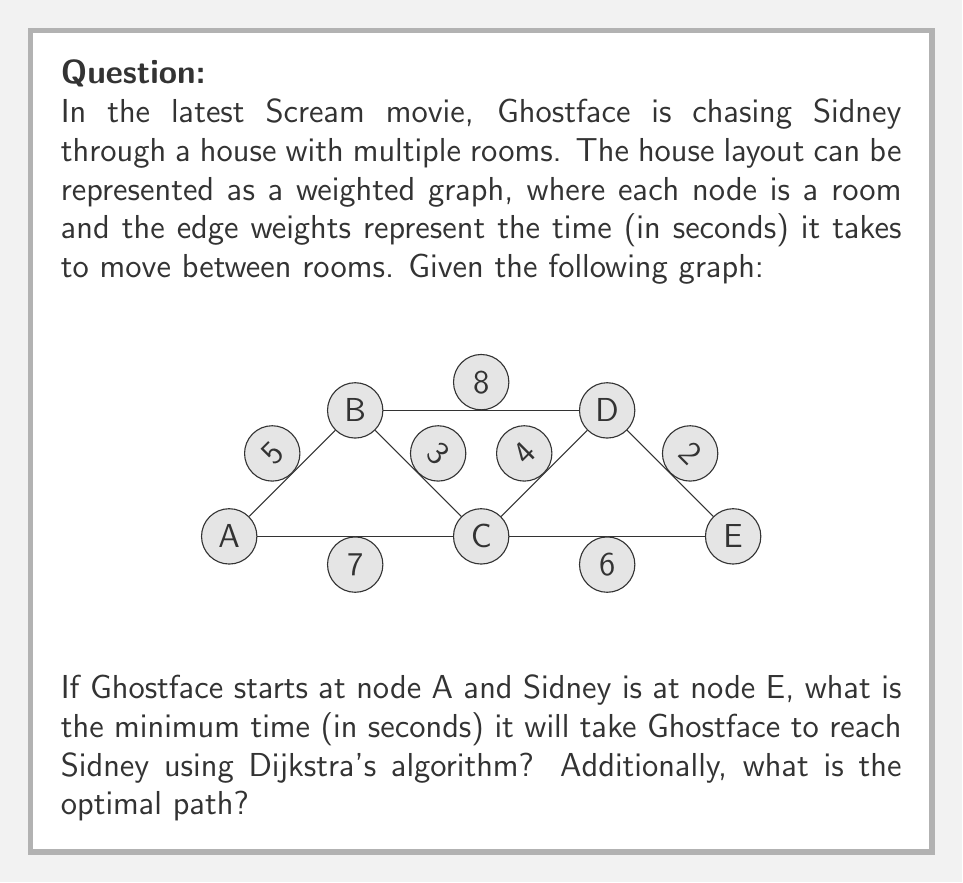Show me your answer to this math problem. To solve this problem, we'll use Dijkstra's algorithm to find the shortest path from node A to node E. Let's go through the steps:

1) Initialize:
   - Distance to A: 0
   - Distance to all other nodes: ∞
   - Set of unvisited nodes: {A, B, C, D, E}

2) From A, we can reach:
   - B with distance 5
   - C with distance 7
   Update distances: A(0), B(5), C(7), D(∞), E(∞)

3) Select node with minimum distance (A), mark as visited:
   Unvisited: {B, C, D, E}

4) From B, we can reach:
   - C: min(7, 5+3) = 7
   - D: min(∞, 5+8) = 13
   Update distances: A(0), B(5), C(7), D(13), E(∞)

5) Select node with minimum distance (B), mark as visited:
   Unvisited: {C, D, E}

6) From C, we can reach:
   - D: min(13, 7+4) = 11
   - E: min(∞, 7+6) = 13
   Update distances: A(0), B(5), C(7), D(11), E(13)

7) Select node with minimum distance (C), mark as visited:
   Unvisited: {D, E}

8) From D, we can reach:
   - E: min(13, 11+2) = 13
   No updates needed

9) Select node with minimum distance (D), mark as visited:
   Unvisited: {E}

10) E is the target node, so we're done.

The minimum time to reach E is 13 seconds.
The optimal path is A → C → E.
Answer: 13 seconds; Path: A → C → E 